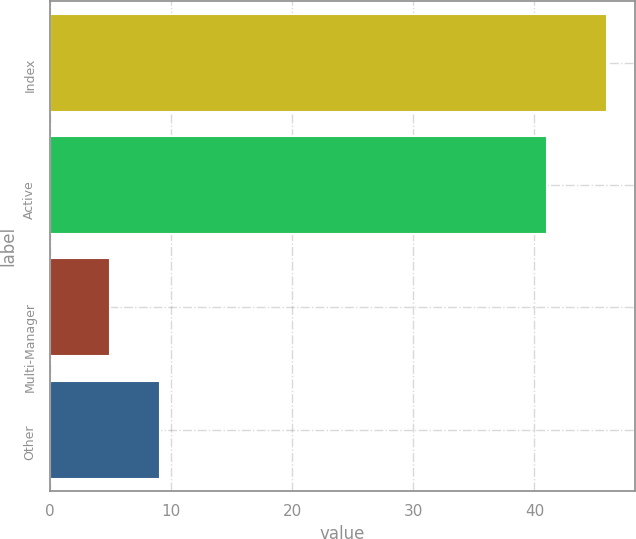Convert chart. <chart><loc_0><loc_0><loc_500><loc_500><bar_chart><fcel>Index<fcel>Active<fcel>Multi-Manager<fcel>Other<nl><fcel>46<fcel>41<fcel>5<fcel>9.1<nl></chart> 